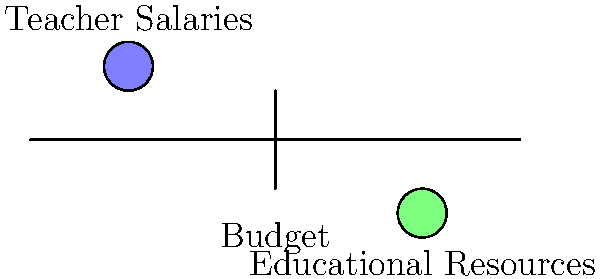In the seesaw diagram above, which represents a school district's budget allocation, what would be the likely outcome if the weight on the "Teacher Salaries" side were to increase significantly? To answer this question, let's consider the mechanics of a seesaw and how it relates to budget allocation:

1. The seesaw represents the school district's total budget.
2. The left side represents teacher salaries, while the right side represents other educational resources.
3. In a balanced budget, both sides would be level.

Now, let's analyze what happens when teacher salaries increase:

1. Increasing teacher salaries adds more "weight" to the left side of the seesaw.
2. For the seesaw to remain balanced (i.e., for the budget to remain balanced), something must change on the right side.
3. Since the total budget (represented by the length of the seesaw) is typically fixed, the only way to balance the seesaw is to reduce the weight on the right side.
4. Reducing the weight on the right side means decreasing the allocation for other educational resources.

Therefore, a significant increase in teacher salaries would likely result in a decrease in funding for other educational resources, assuming the total budget remains constant.

This trade-off illustrates the economic concept of opportunity cost: choosing to spend more in one area necessitates spending less in another, given a fixed budget.
Answer: Decrease in funding for other educational resources 